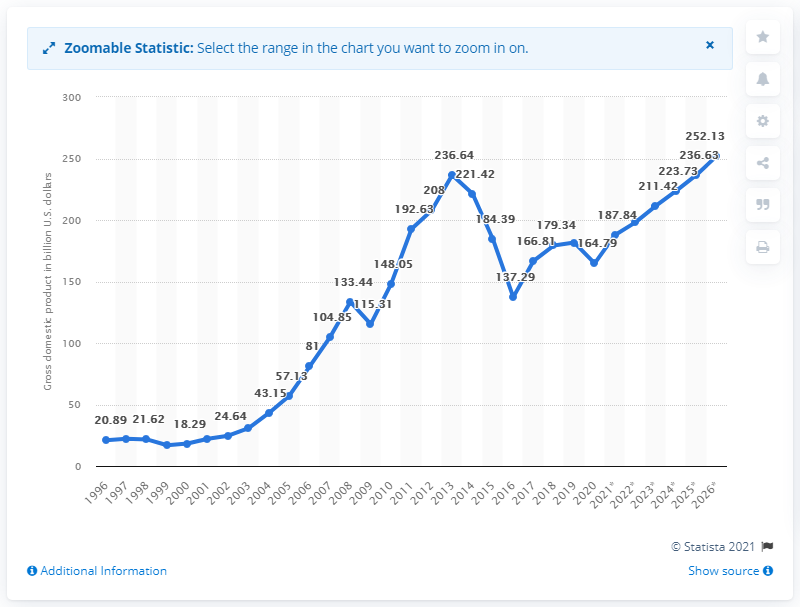Specify some key components in this picture. In 2020, Kazakhstan's gross domestic product was estimated to be 164.79 billion dollars. 